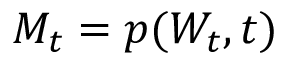Convert formula to latex. <formula><loc_0><loc_0><loc_500><loc_500>M _ { t } = p ( W _ { t } , t )</formula> 